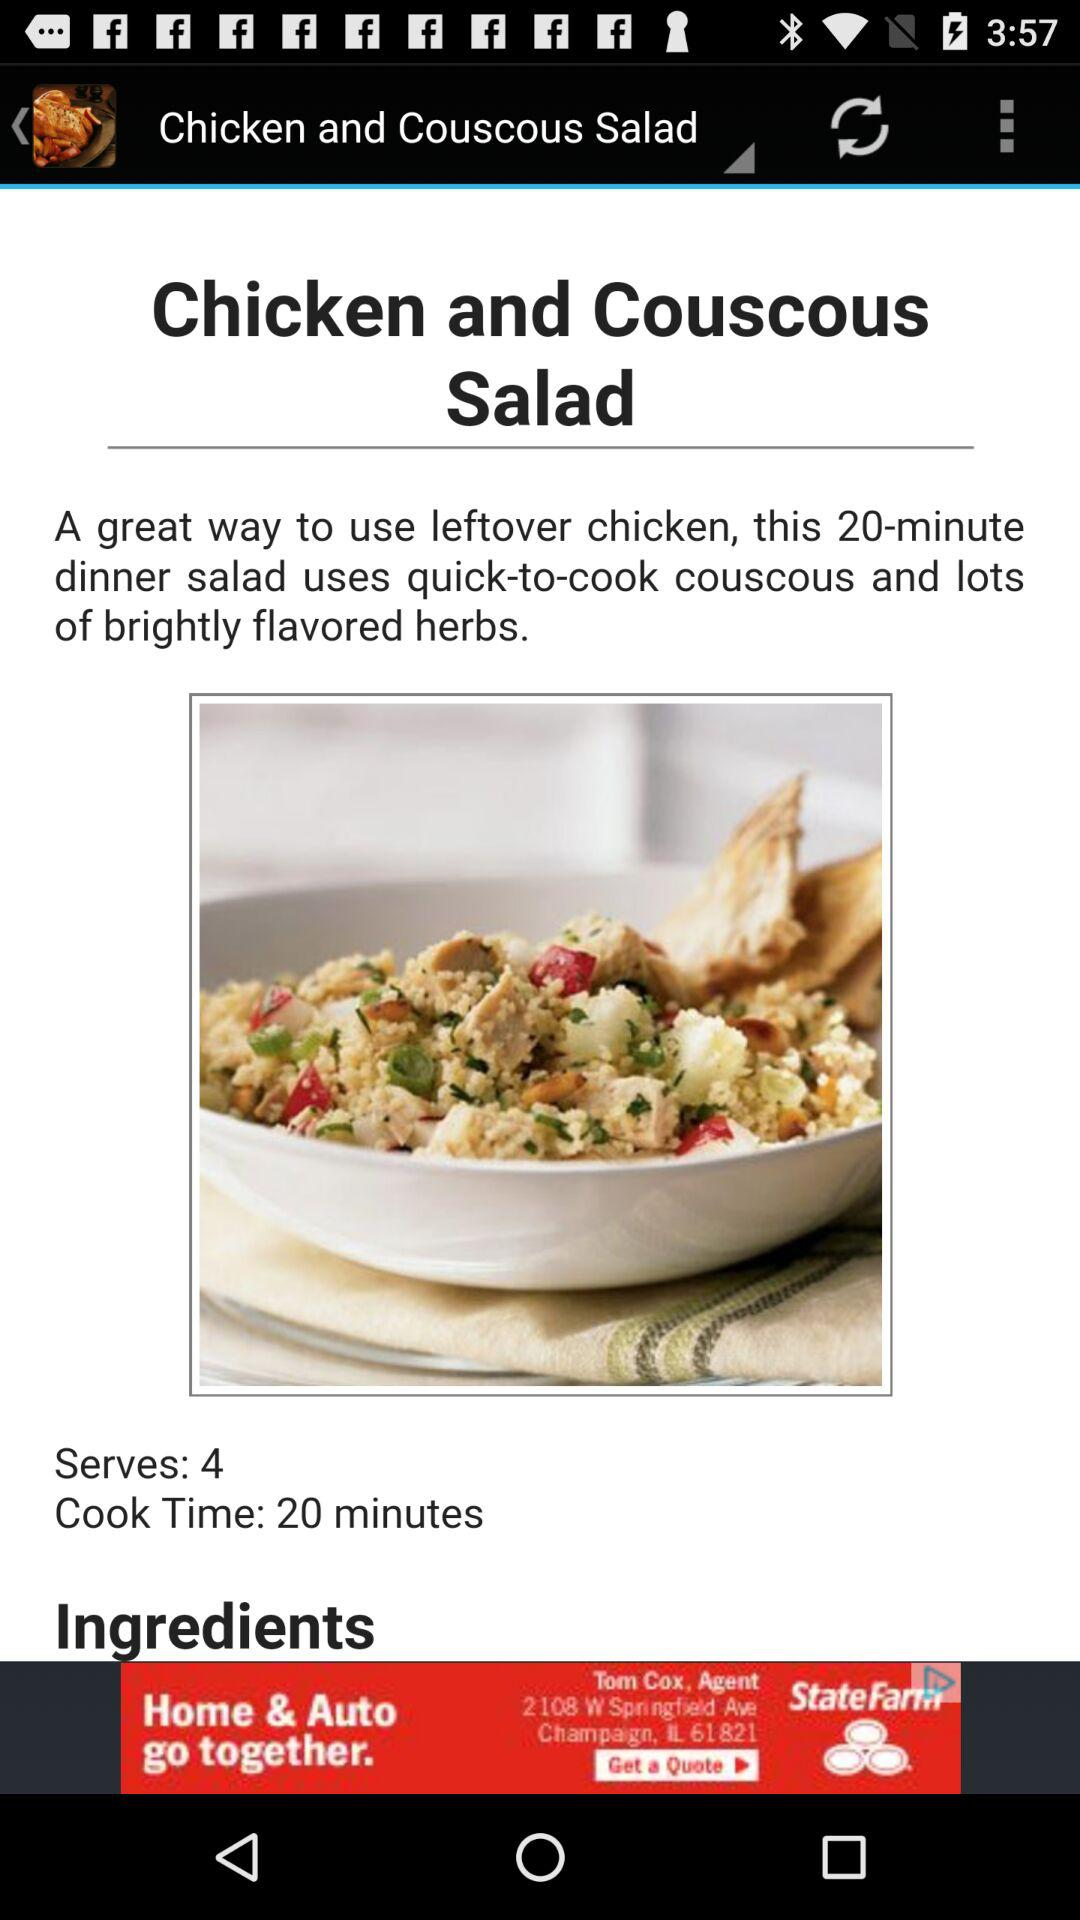What is the name of the recipe? The name of the recipe is "Chicken and Couscous Salad". 